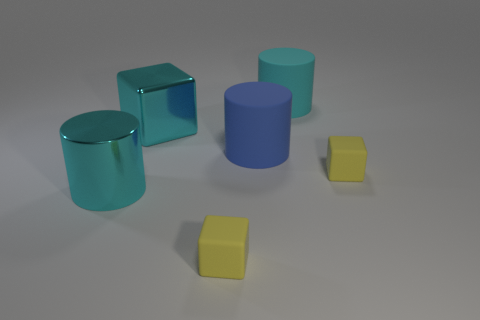What is the shape of the shiny object in front of the large rubber thing that is in front of the big metallic cube?
Keep it short and to the point. Cylinder. There is a blue object; is it the same shape as the cyan object on the right side of the large cube?
Ensure brevity in your answer.  Yes. How many big cyan objects are right of the big metallic object that is left of the cyan metallic cube?
Offer a terse response. 2. There is a blue thing that is the same shape as the cyan rubber thing; what material is it?
Offer a terse response. Rubber. What number of blue objects are either big things or rubber cylinders?
Your answer should be compact. 1. Is there anything else that is the same color as the shiny cylinder?
Ensure brevity in your answer.  Yes. What color is the large cylinder that is to the left of the rubber thing that is on the left side of the blue rubber cylinder?
Offer a terse response. Cyan. Is the number of small yellow objects that are in front of the shiny cylinder less than the number of big objects on the right side of the blue thing?
Offer a very short reply. No. What material is the block that is the same color as the large shiny cylinder?
Ensure brevity in your answer.  Metal. What number of objects are big cyan things that are behind the large cyan cube or large blue rubber objects?
Your answer should be very brief. 2. 